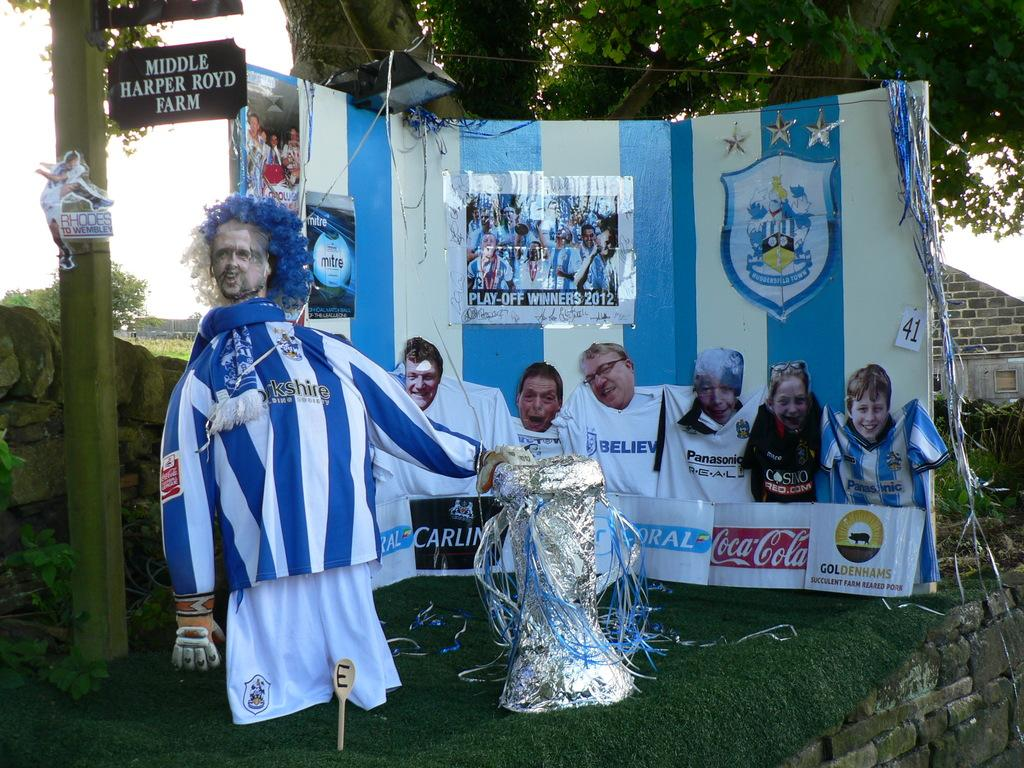What type of signs can be seen in the image? There are advertisements in the image. What structure is present on a pole in the image? There is an information board on a pole in the image. What type of natural elements are visible in the image? There are trees and stones in the image. What type of man-made structures can be seen in the image? There are buildings in the image. What object in the image might be a souvenir or keepsake? There is a memento in the image. What part of the natural environment is visible in the image? The sky is visible in the image. How many girls are singing in the image? There are no girls or singing present in the image. What direction is the voice coming from in the image? There is no voice present in the image. 